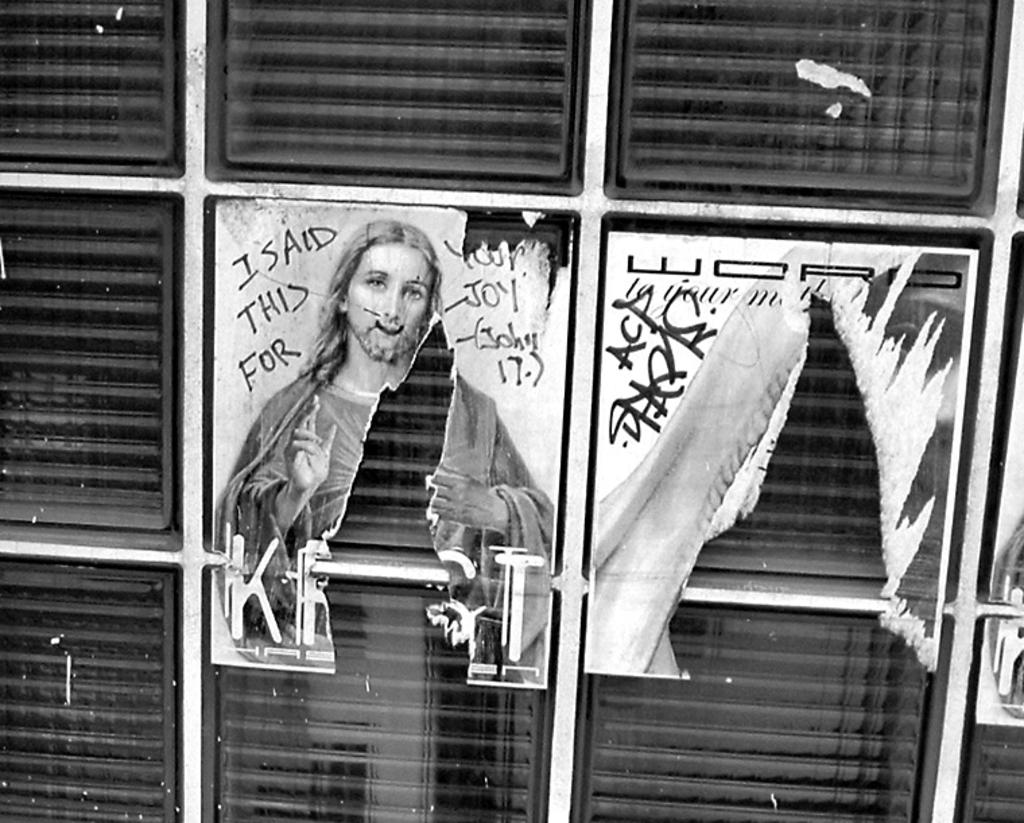What is the focus of the image? The image is zoomed in on a black color object, which appears to be a cabinet. What can be seen on the cabinet? There is a picture of a person and text on the cabinet. What type of secretary is sitting on the roof in the image? There is no secretary or roof present in the image; it features a cabinet with a picture of a person and text. 